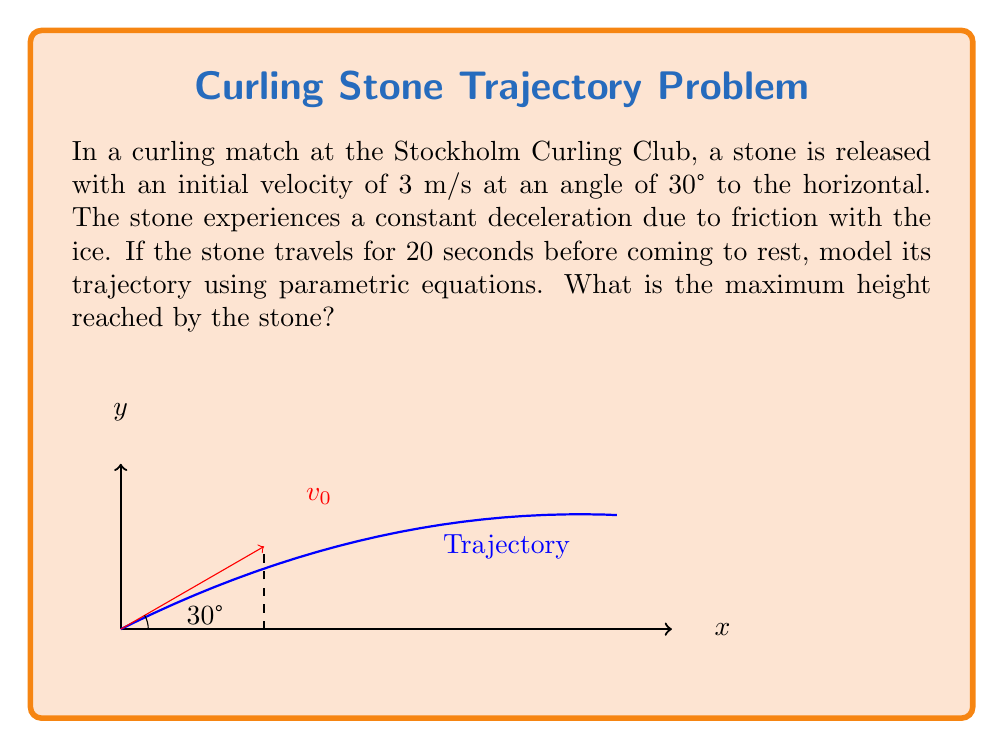Show me your answer to this math problem. Let's approach this step-by-step:

1) First, we need to set up our parametric equations. The general form for projectile motion is:

   $$x(t) = v_0 \cos(\theta) t + \frac{1}{2}a_x t^2$$
   $$y(t) = v_0 \sin(\theta) t - \frac{1}{2}gt^2$$

   Where $v_0$ is the initial velocity, $\theta$ is the launch angle, $g$ is acceleration due to gravity, and $a_x$ is the horizontal acceleration.

2) We're given:
   $v_0 = 3$ m/s
   $\theta = 30° = \frac{\pi}{6}$ radians
   Total time of motion, $T = 20$ seconds

3) To find $a_x$, we can use the fact that the stone comes to rest after 20 seconds:

   $$v_x(T) = v_0 \cos(\theta) + a_x T = 0$$
   $$a_x = -\frac{v_0 \cos(\theta)}{T} = -\frac{3 \cos(\frac{\pi}{6})}{20} = -0.13 \text{ m/s}^2$$

4) Now we can write our parametric equations:

   $$x(t) = 3 \cos(\frac{\pi}{6}) t - 0.065t^2$$
   $$y(t) = 3 \sin(\frac{\pi}{6}) t - 4.9t^2$$

5) To find the maximum height, we need to find when $\frac{dy}{dt} = 0$:

   $$\frac{dy}{dt} = 3 \sin(\frac{\pi}{6}) - 9.8t = 0$$
   $$t = \frac{3 \sin(\frac{\pi}{6})}{9.8} = 0.153 \text{ seconds}$$

6) Plug this time back into the y-equation:

   $$y_{max} = 3 \sin(\frac{\pi}{6}) (0.153) - 4.9(0.153)^2 = 0.115 \text{ meters}$$
Answer: 0.115 m 